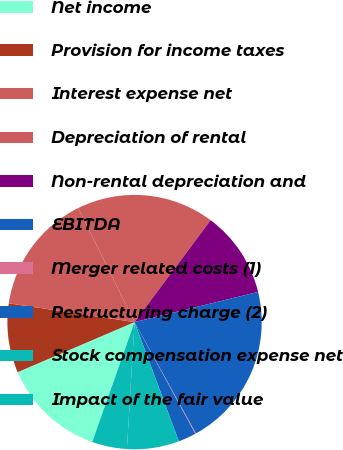<chart> <loc_0><loc_0><loc_500><loc_500><pie_chart><fcel>Net income<fcel>Provision for income taxes<fcel>Interest expense net<fcel>Depreciation of rental<fcel>Non-rental depreciation and<fcel>EBITDA<fcel>Merger related costs (1)<fcel>Restructuring charge (2)<fcel>Stock compensation expense net<fcel>Impact of the fair value<nl><fcel>13.16%<fcel>8.8%<fcel>15.34%<fcel>17.51%<fcel>10.98%<fcel>20.8%<fcel>0.09%<fcel>2.26%<fcel>6.62%<fcel>4.44%<nl></chart> 